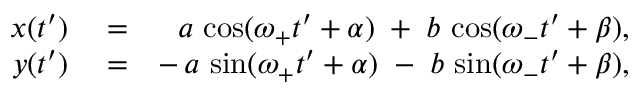Convert formula to latex. <formula><loc_0><loc_0><loc_500><loc_500>\begin{array} { r l r } { x ( t ^ { \prime } ) } & = } & { a \, \cos ( \omega _ { + } t ^ { \prime } + \alpha ) \, + \, b \, \cos ( \omega _ { - } t ^ { \prime } + \beta ) , } \\ { y ( t ^ { \prime } ) } & = } & { - \, a \, \sin ( \omega _ { + } t ^ { \prime } + \alpha ) \, - \, b \, \sin ( \omega _ { - } t ^ { \prime } + \beta ) , } \end{array}</formula> 